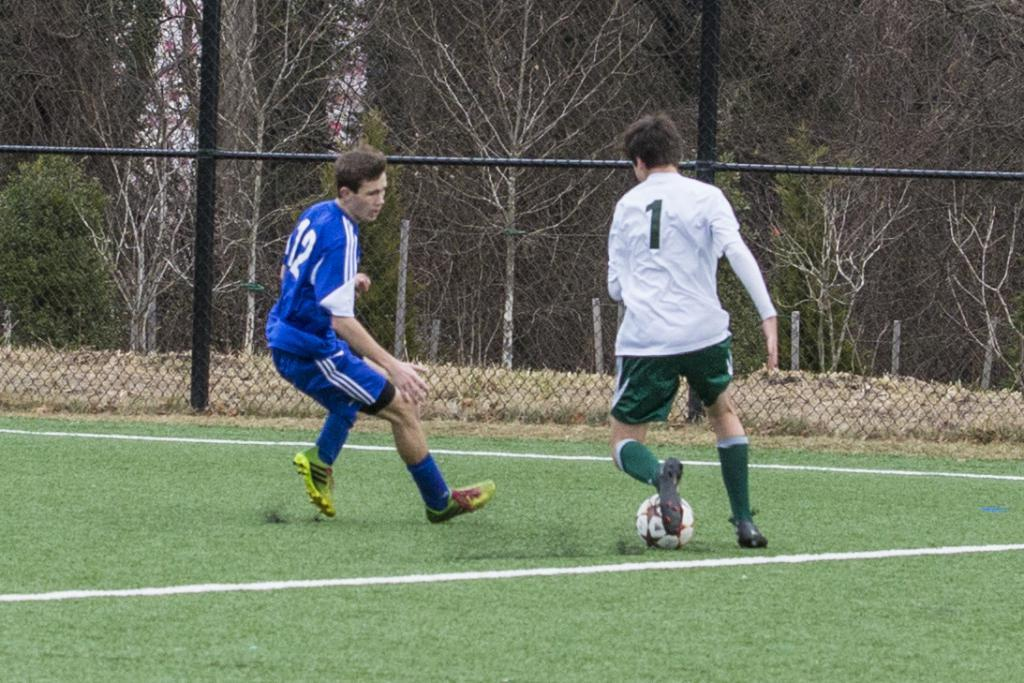<image>
Create a compact narrative representing the image presented. A man with a white soccer shirt with a 1 on the back kicks a soccer ball. 